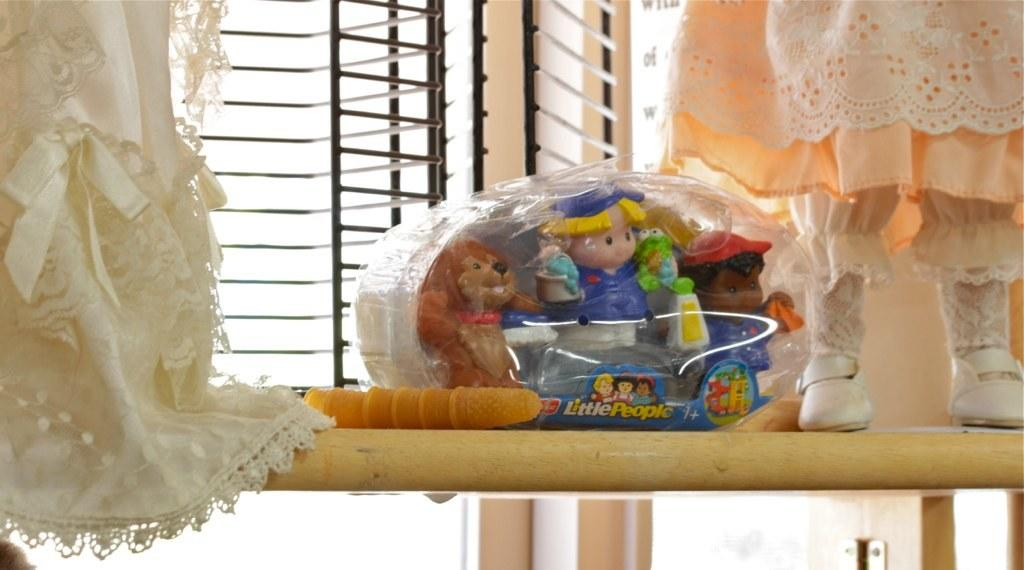What is the main object in the image? There is a wooden board in the image. What is placed on the wooden board? There is a dress and toys on the wooden board. What can be seen in the background of the image? There is a window grill and a wall in the background of the image. What is located at the bottom of the image? There are objects at the bottom of the image. What arithmetic problem is being solved on the wooden board? There is no arithmetic problem visible on the wooden board in the image. What type of teeth can be seen on the wooden board? There are no teeth present on the wooden board in the image. 